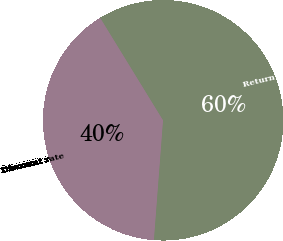<chart> <loc_0><loc_0><loc_500><loc_500><pie_chart><fcel>Discount rate<fcel>Return on plan assets<nl><fcel>40.03%<fcel>59.97%<nl></chart> 